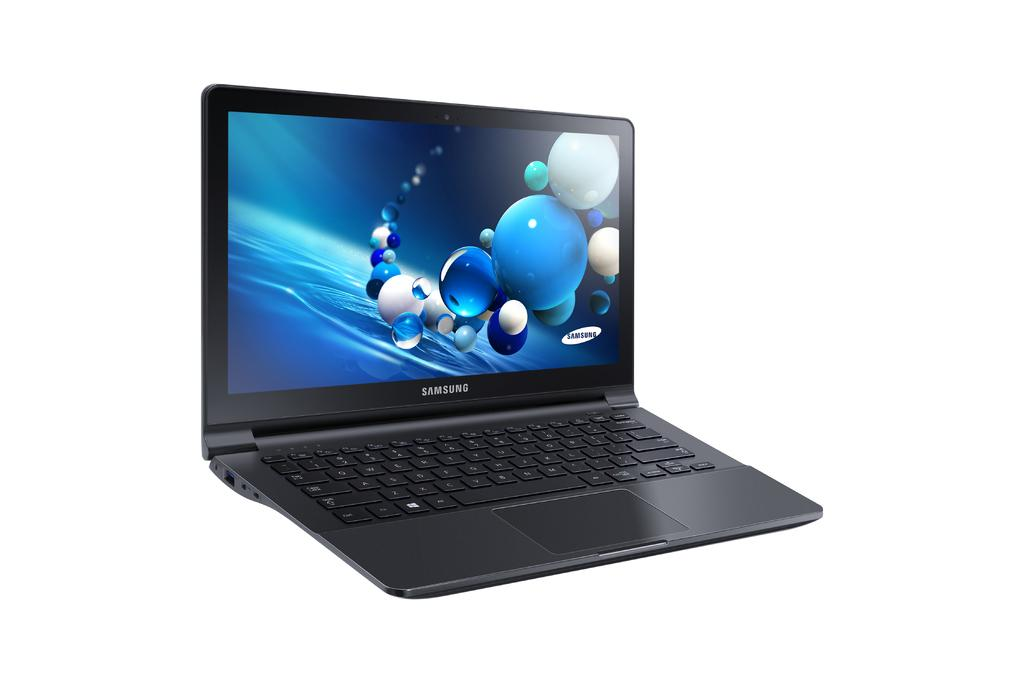<image>
Provide a brief description of the given image. a samsung laptop with balls on the screen 